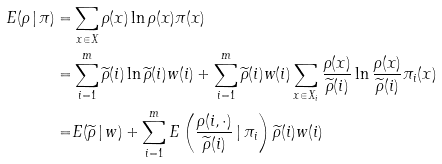Convert formula to latex. <formula><loc_0><loc_0><loc_500><loc_500>E ( \rho \, | \, \pi ) = & \sum _ { x \in X } \rho ( x ) \ln \rho ( x ) \pi ( x ) \\ = & \sum _ { i = 1 } ^ { m } \widetilde { \rho } ( i ) \ln \widetilde { \rho } ( i ) w ( i ) + \sum _ { i = 1 } ^ { m } \widetilde { \rho } ( i ) w ( i ) \sum _ { x \in X _ { i } } \frac { \rho ( x ) } { \widetilde { \rho } ( i ) } \ln \frac { \rho ( x ) } { \widetilde { \rho } ( i ) } \pi _ { i } ( x ) \\ = & E ( \widetilde { \rho } \, | \, w ) + \sum _ { i = 1 } ^ { m } E \left ( \frac { \rho ( i , \cdot ) } { \widetilde { \rho } ( i ) } \, | \, \pi _ { i } \right ) \widetilde { \rho } ( i ) w ( i )</formula> 